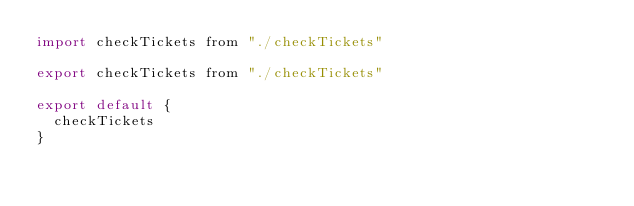Convert code to text. <code><loc_0><loc_0><loc_500><loc_500><_JavaScript_>import checkTickets from "./checkTickets"

export checkTickets from "./checkTickets"

export default {
  checkTickets
}
</code> 